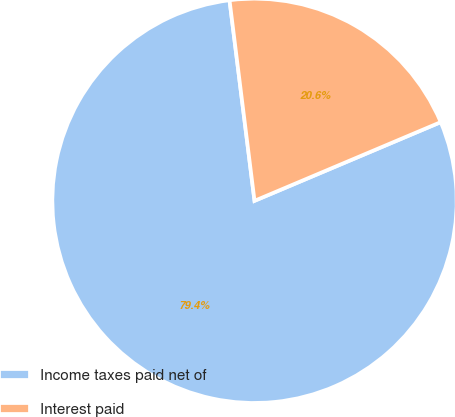<chart> <loc_0><loc_0><loc_500><loc_500><pie_chart><fcel>Income taxes paid net of<fcel>Interest paid<nl><fcel>79.39%<fcel>20.61%<nl></chart> 